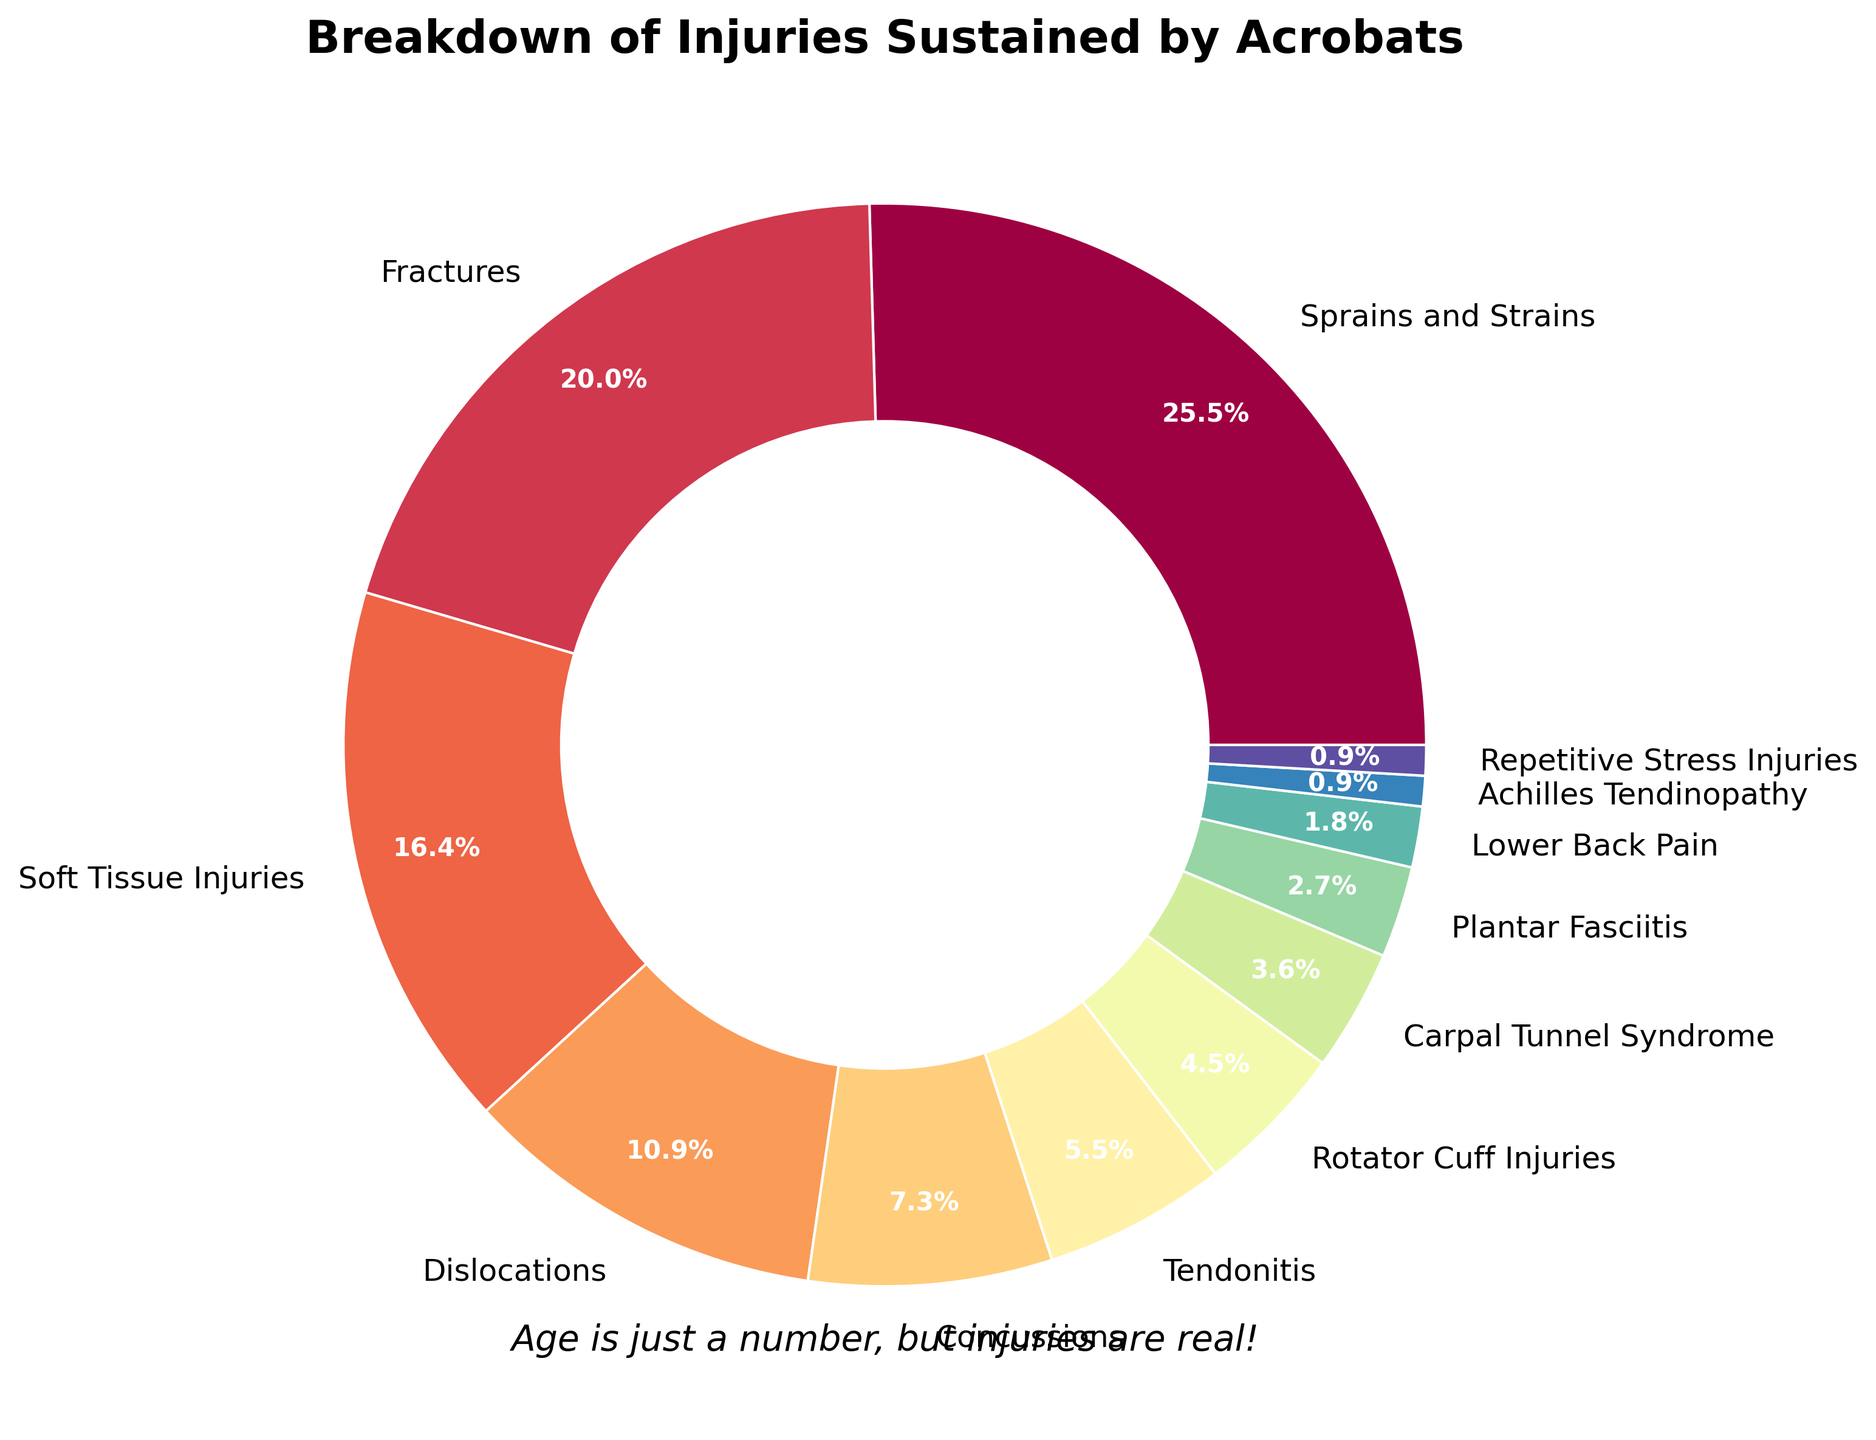What injury type has the highest percentage? The pie chart shows the percentage each type of injury accounts for. By observing the slices, "Sprains and Strains" has the largest portion of the pie.
Answer: Sprains and Strains Which category has a higher percentage of injuries: Fractures or Soft Tissue Injuries? By comparing the pie slices, "Fractures" make up 22%, while "Soft Tissue Injuries" make up 18%. Therefore, "Fractures" has a higher percentage.
Answer: Fractures What is the total percentage of injuries that are soft tissue related (Soft Tissue Injuries, Tendonitis, Rotator Cuff Injuries)? Sum the percentages for "Soft Tissue Injuries" (18%), "Tendonitis" (6%), and "Rotator Cuff Injuries" (5%). 18 + 6 + 5 = 29.
Answer: 29% Which injury type accounts for one of the smallest portions of the pie? By looking at the smallest slices, "Achilles Tendinopathy" and "Repetitive Stress Injuries" both account for 1% of the injuries.
Answer: Achilles Tendinopathy or Repetitive Stress Injuries How much more common are Sprains and Strains compared to Lower Back Pain? Subtract the percentage of "Lower Back Pain" (2%) from "Sprains and Strains" (28%). 28 - 2 = 26.
Answer: 26% Is the percentage of Dislocations more or less than half of the Sprains and Strains percentage? The "Dislocations" account for 12%, and "Sprains and Strains" account for 28%. Half of 28% is 14%, so 12% is less than half.
Answer: Less Which injury types represent less than 5% each, and what is their combined percentage? Identify the injury types with less than 5%: "Carpal Tunnel Syndrome" (4%), "Plantar Fasciitis" (3%), "Lower Back Pain" (2%), "Achilles Tendinopathy" (1%), "Repetitive Stress Injuries" (1%). Sum these percentages: 4 + 3 + 2 + 1 + 1 = 11.
Answer: Carpal Tunnel Syndrome, Plantar Fasciitis, Lower Back Pain, Achilles Tendinopathy, Repetitive Stress Injuries; 11% What is the difference between the percentage of Concussions and Tendonitis? Subtract the percentage of "Tendonitis" (6%) from "Concussions" (8%). 8 - 6 = 2.
Answer: 2% Which categories appear visually similar in size on the pie chart? By observing the pie slices, "Dislocations" (12%) and "Concussions" (8%) appear similar in size to "Soft Tissue Injuries" (18%) and "Fractures" (22%) when grouped closely.
Answer: Dislocations and Concussions, Soft Tissue Injuries and Fractures 